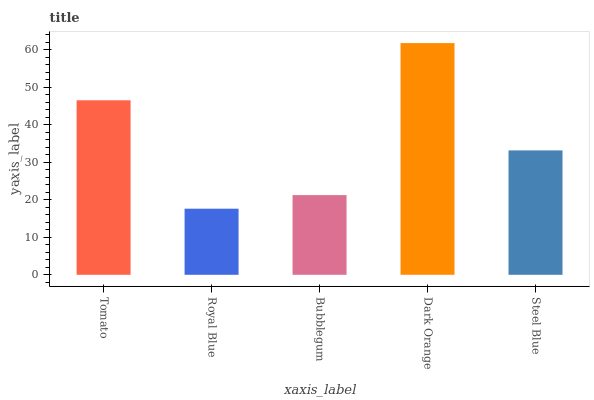Is Royal Blue the minimum?
Answer yes or no. Yes. Is Dark Orange the maximum?
Answer yes or no. Yes. Is Bubblegum the minimum?
Answer yes or no. No. Is Bubblegum the maximum?
Answer yes or no. No. Is Bubblegum greater than Royal Blue?
Answer yes or no. Yes. Is Royal Blue less than Bubblegum?
Answer yes or no. Yes. Is Royal Blue greater than Bubblegum?
Answer yes or no. No. Is Bubblegum less than Royal Blue?
Answer yes or no. No. Is Steel Blue the high median?
Answer yes or no. Yes. Is Steel Blue the low median?
Answer yes or no. Yes. Is Bubblegum the high median?
Answer yes or no. No. Is Dark Orange the low median?
Answer yes or no. No. 